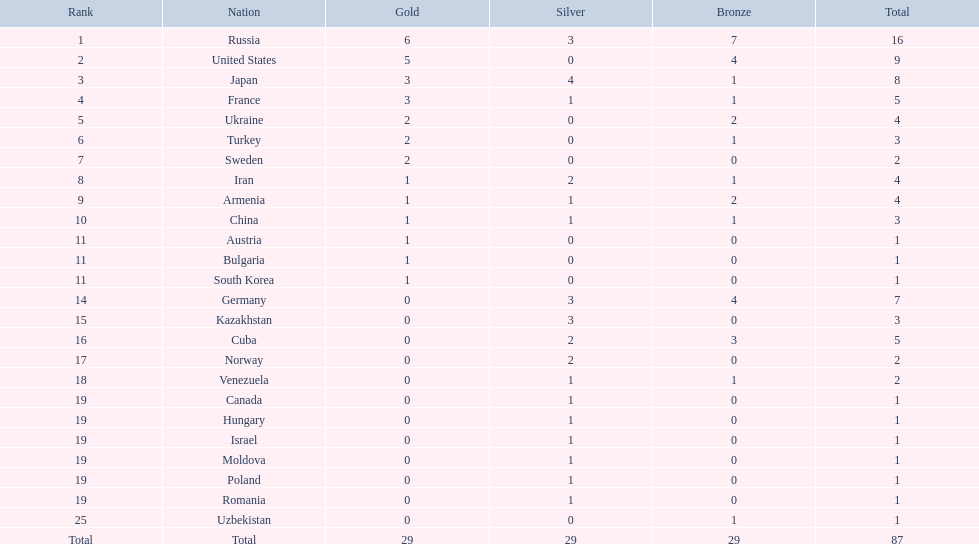Which countries competed in the 1995 world wrestling championships? Russia, United States, Japan, France, Ukraine, Turkey, Sweden, Iran, Armenia, China, Austria, Bulgaria, South Korea, Germany, Kazakhstan, Cuba, Norway, Venezuela, Canada, Hungary, Israel, Moldova, Poland, Romania, Uzbekistan. What country won only one medal? Austria, Bulgaria, South Korea, Canada, Hungary, Israel, Moldova, Poland, Romania, Uzbekistan. Which of these won a bronze medal? Uzbekistan. 